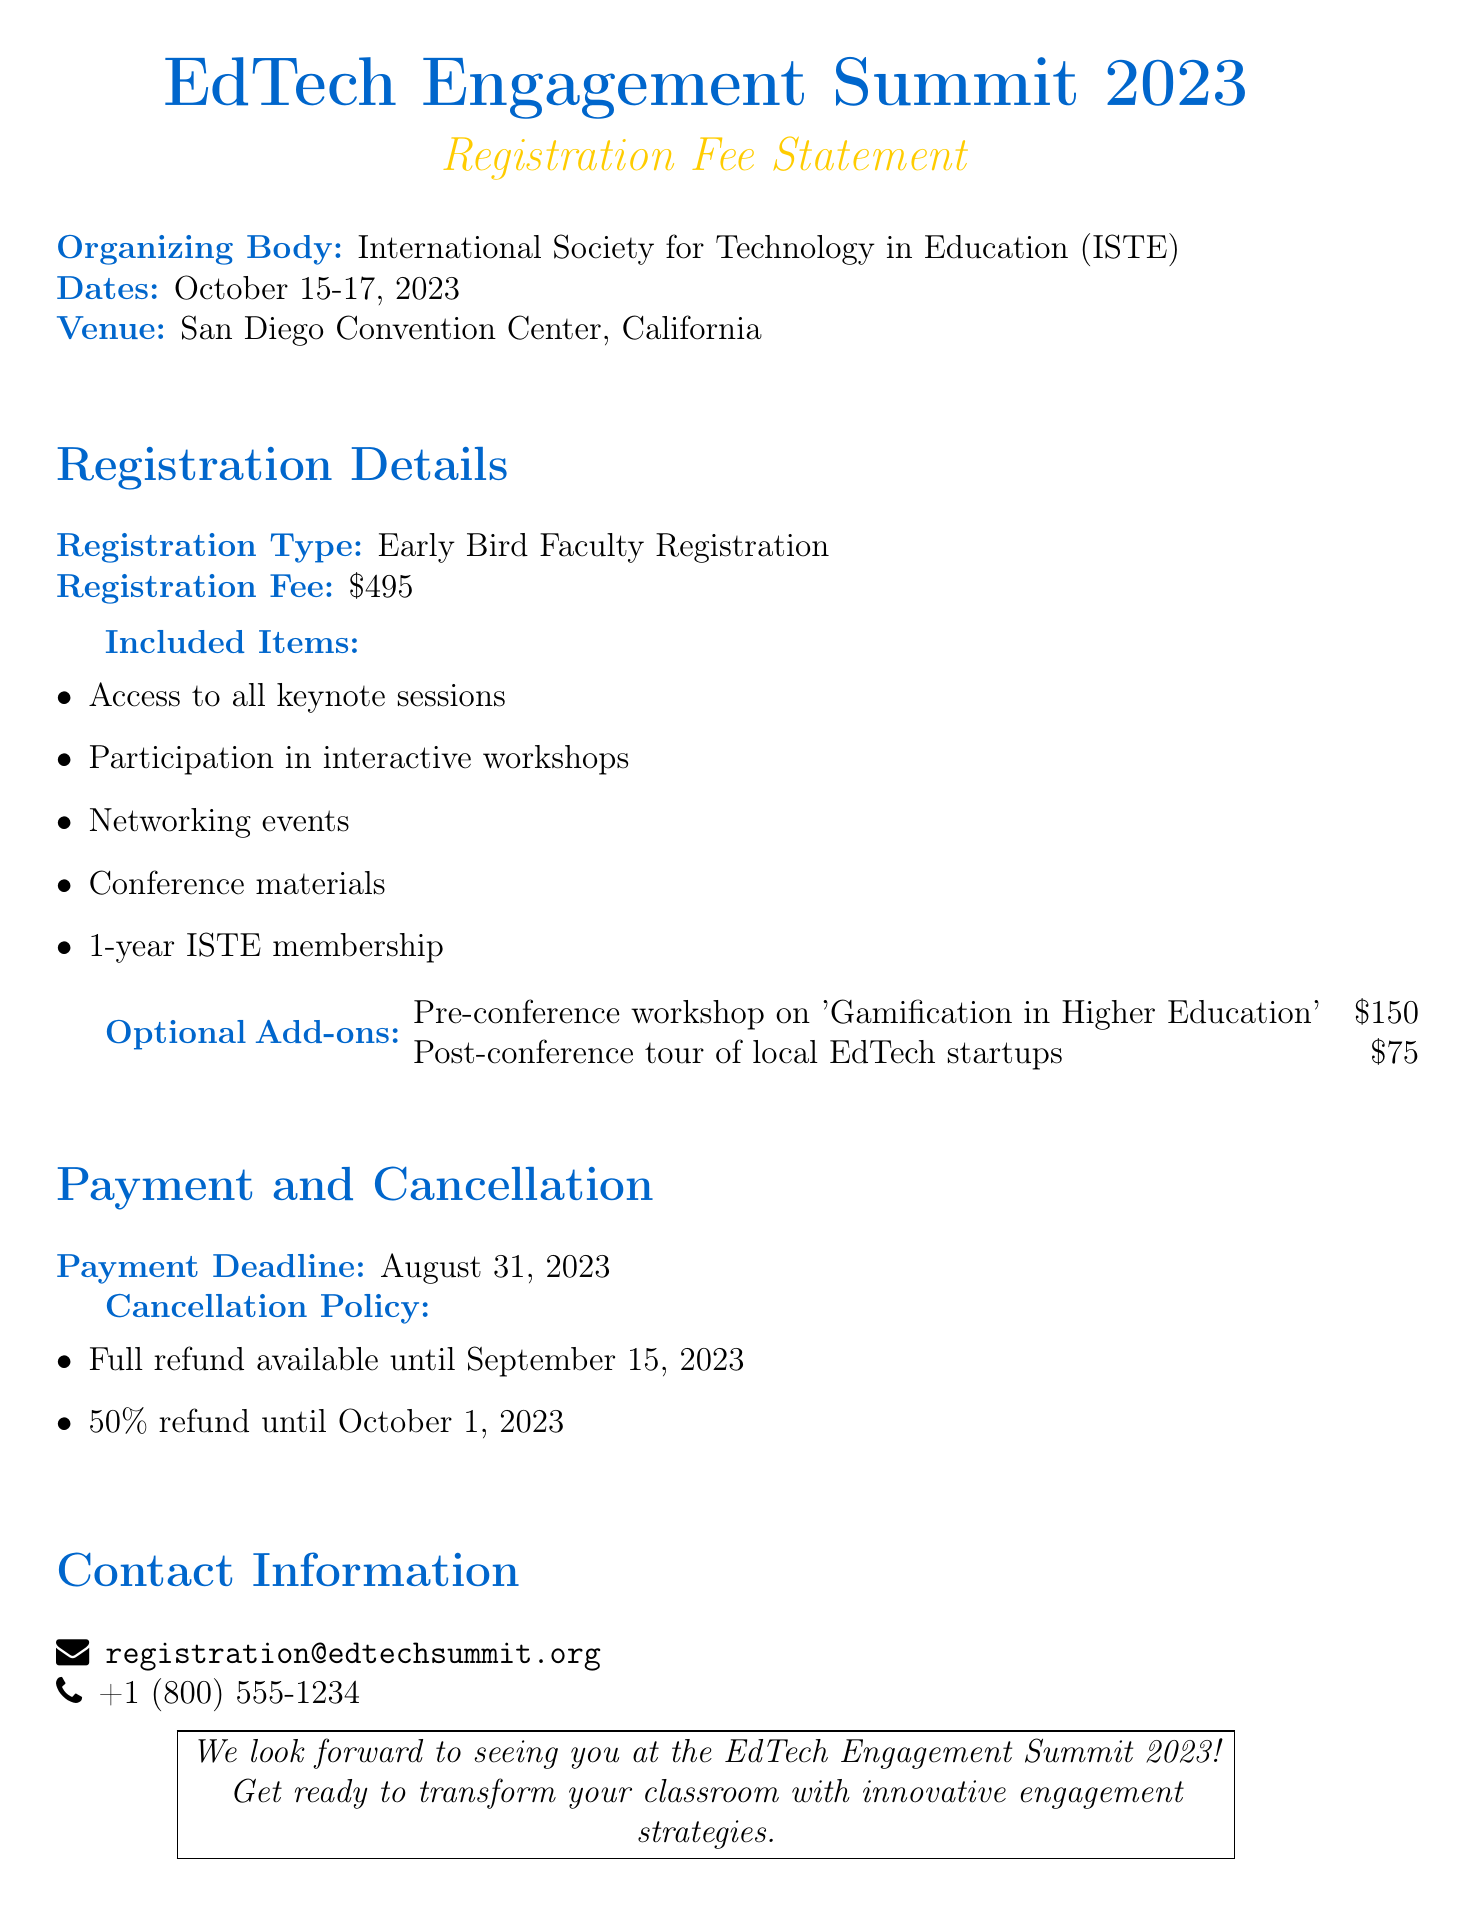What is the registration fee for faculty? The registration fee for faculty is specified in the document as the primary cost for attending the conference.
Answer: $495 Who is the organizing body of the symposium? The organizing body is mentioned clearly in the document, providing the name of the organization responsible for the event.
Answer: International Society for Technology in Education (ISTE) What is the payment deadline? The payment deadline is crucial for attendees to know when their registration fee must be paid, as stated in the document.
Answer: August 31, 2023 What items are included in the registration fee? The document lists specific items that are part of the registration fee to inform attendees about the benefits they receive.
Answer: Access to all keynote sessions, Participation in interactive workshops, Networking events, Conference materials, 1-year ISTE membership How much is the pre-conference workshop? The specific cost of the pre-conference workshop is detailed in the optional add-ons section of the document.
Answer: $150 What is the full refund deadline? The full refund deadline is important for participants who may reconsider their attendance, as outlined in the cancellation policy.
Answer: September 15, 2023 What type of events can participants access? The document outlines various events participants can join, making it clear what they will be able to experience at the symposium.
Answer: Keynote sessions and interactive workshops What is the cost for the post-conference tour? The cost for the post-conference tour is provided in the section detailing optional add-ons, giving more options to participants.
Answer: $75 